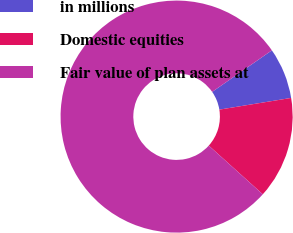Convert chart to OTSL. <chart><loc_0><loc_0><loc_500><loc_500><pie_chart><fcel>in millions<fcel>Domestic equities<fcel>Fair value of plan assets at<nl><fcel>7.1%<fcel>14.25%<fcel>78.65%<nl></chart> 